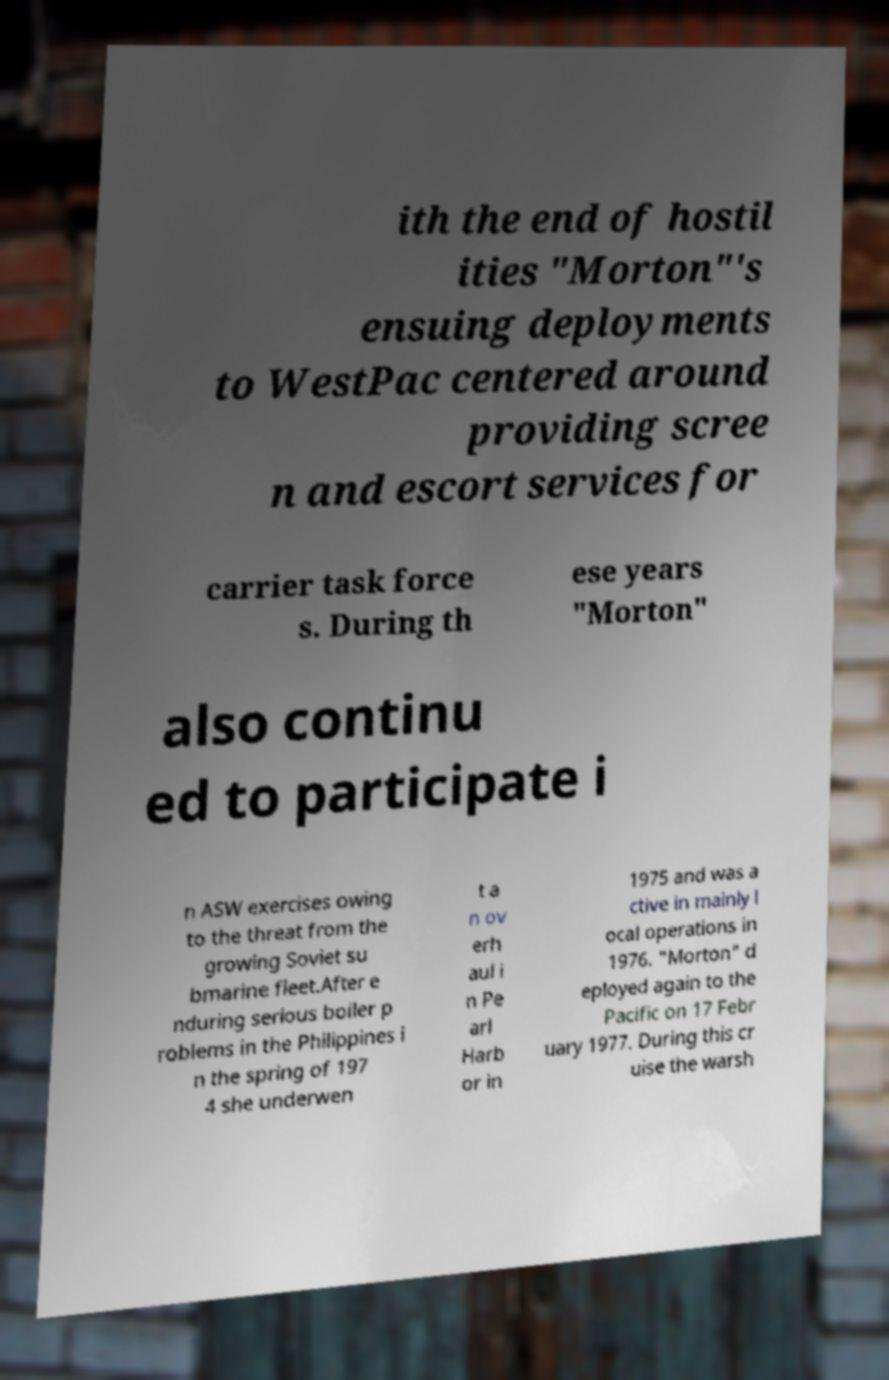For documentation purposes, I need the text within this image transcribed. Could you provide that? ith the end of hostil ities "Morton"'s ensuing deployments to WestPac centered around providing scree n and escort services for carrier task force s. During th ese years "Morton" also continu ed to participate i n ASW exercises owing to the threat from the growing Soviet su bmarine fleet.After e nduring serious boiler p roblems in the Philippines i n the spring of 197 4 she underwen t a n ov erh aul i n Pe arl Harb or in 1975 and was a ctive in mainly l ocal operations in 1976. "Morton" d eployed again to the Pacific on 17 Febr uary 1977. During this cr uise the warsh 